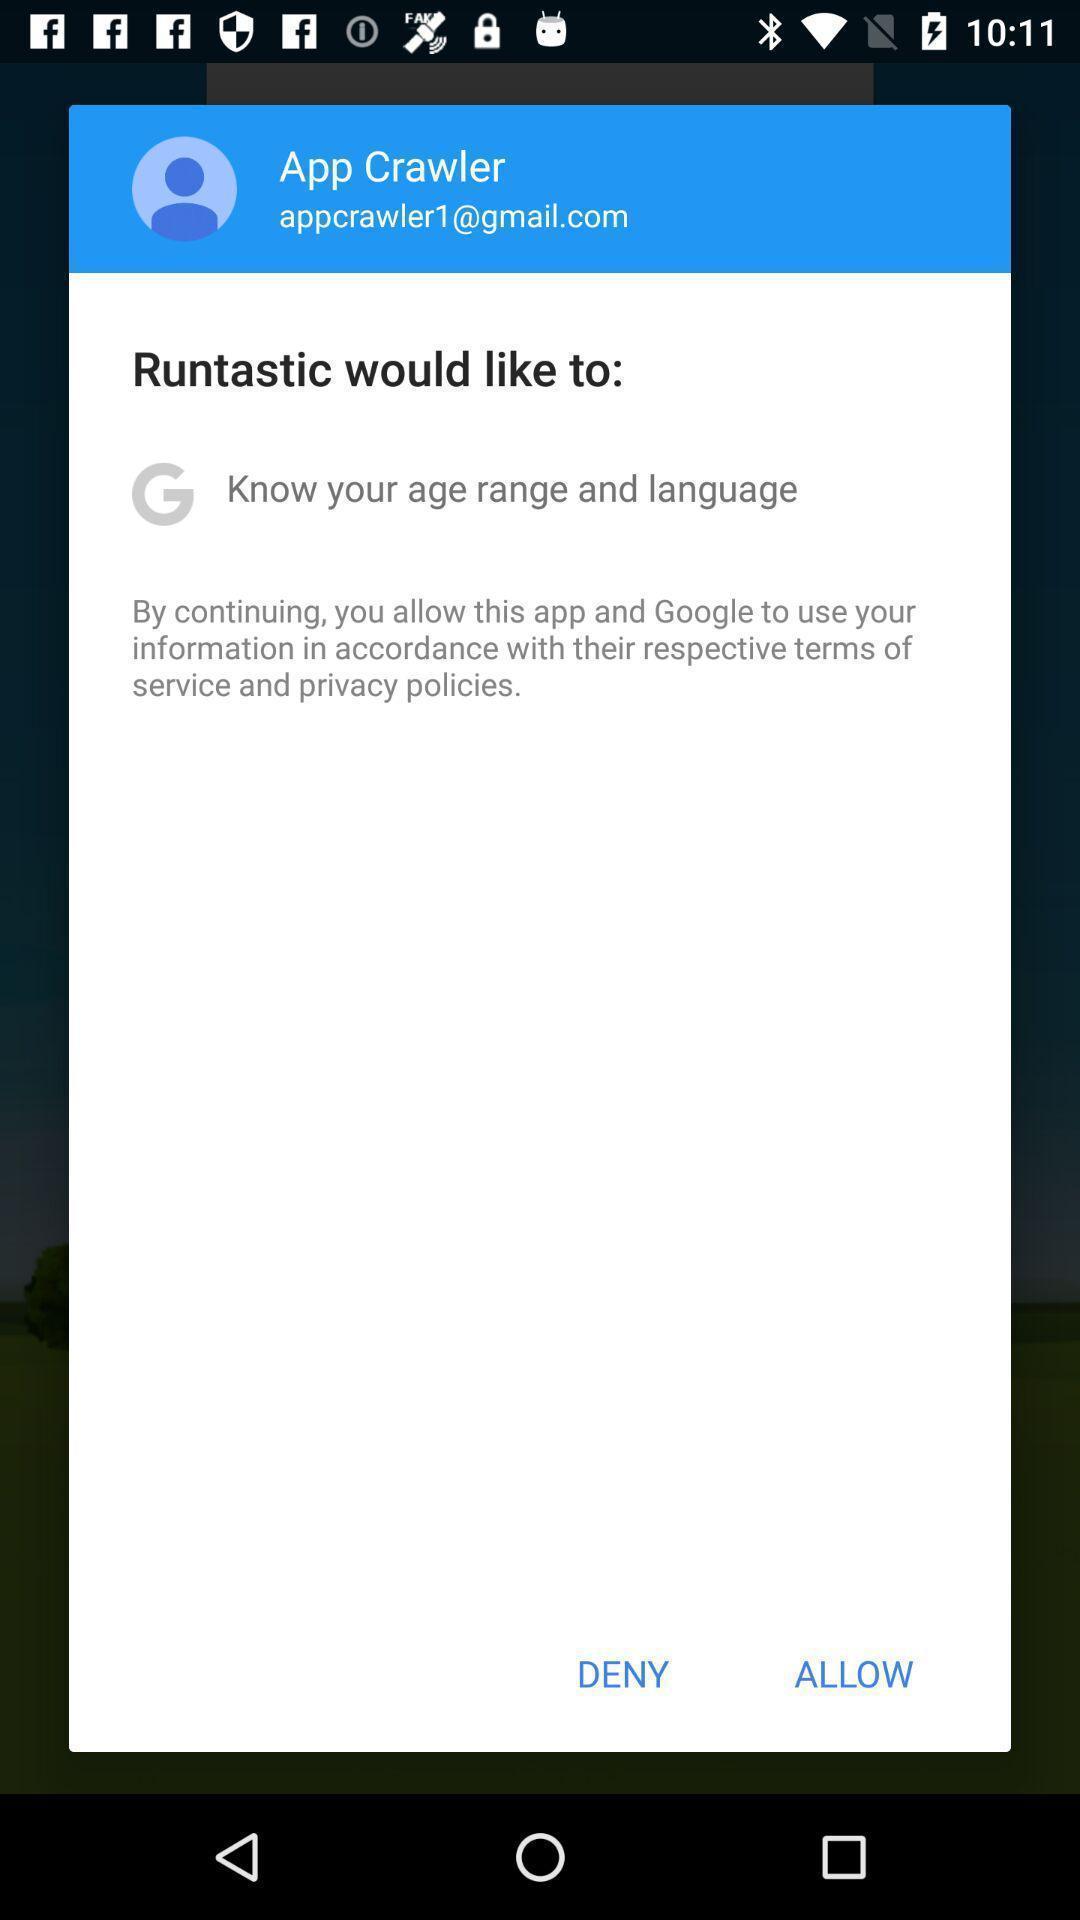Describe the visual elements of this screenshot. Pop-up asking permission to allow for continuation. 